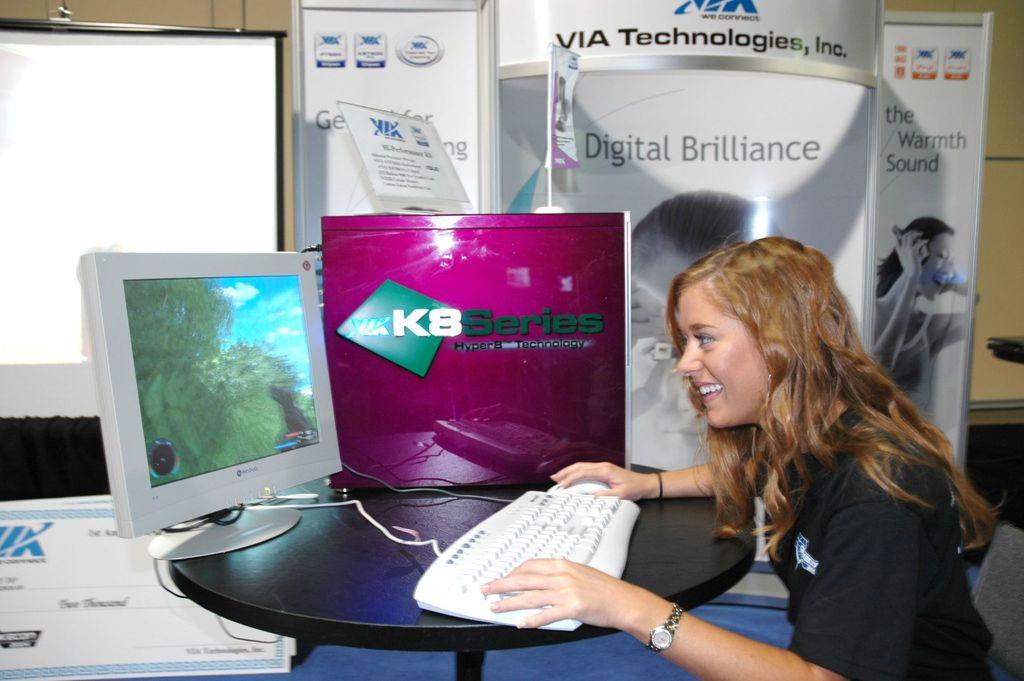What series of computer is this?
Keep it short and to the point. K8. What does the sign say behind the woman?
Ensure brevity in your answer.  Digital brilliance. 